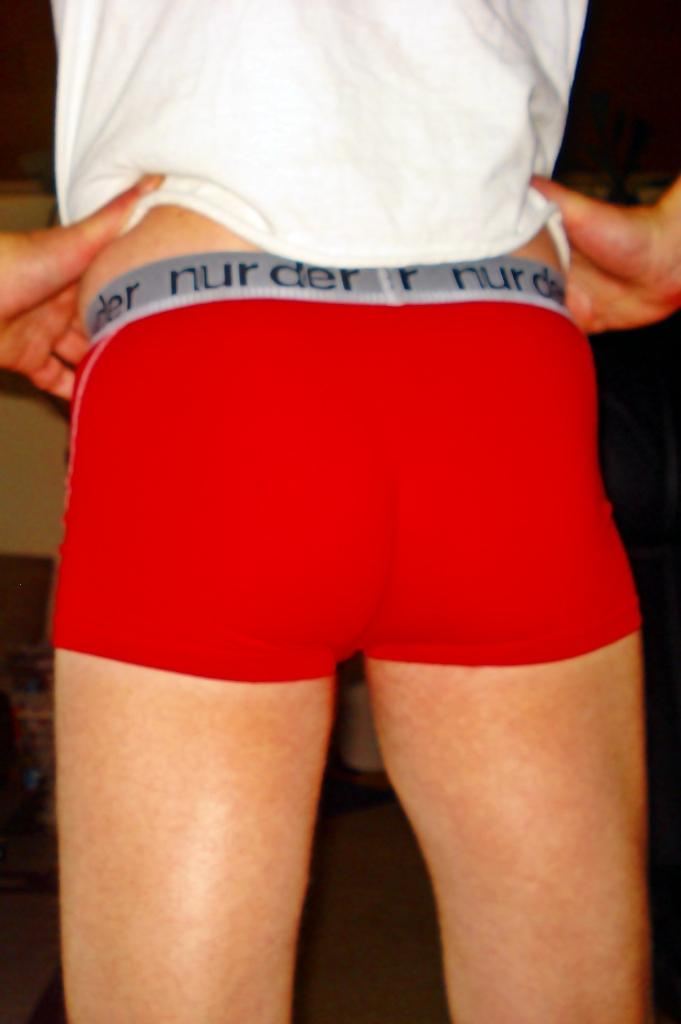<image>
Offer a succinct explanation of the picture presented. A pair of underwear have the words nur der on the band. 